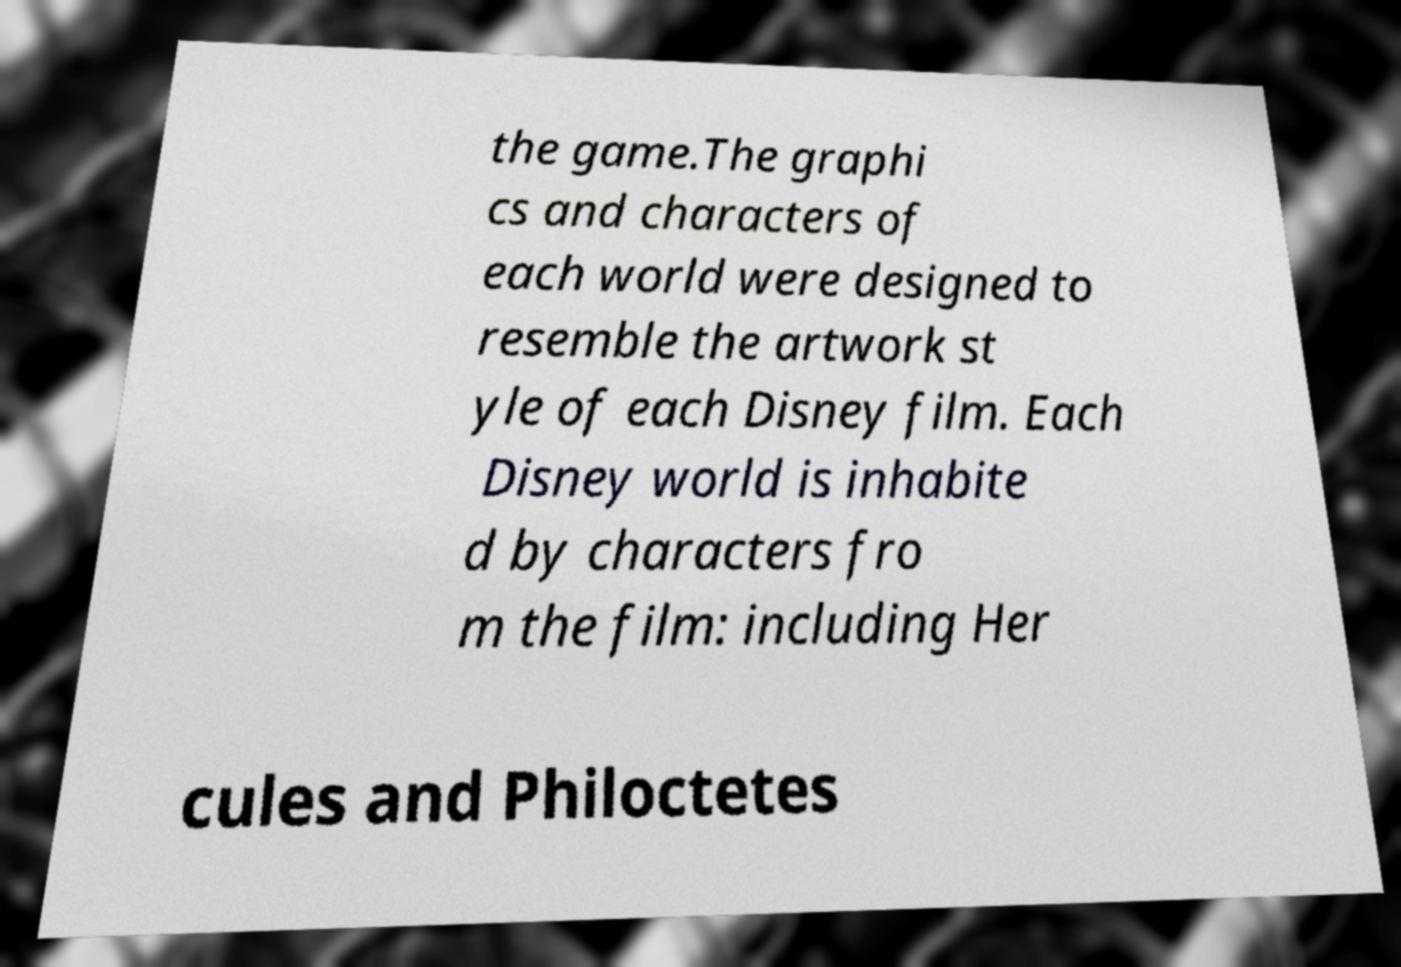What messages or text are displayed in this image? I need them in a readable, typed format. the game.The graphi cs and characters of each world were designed to resemble the artwork st yle of each Disney film. Each Disney world is inhabite d by characters fro m the film: including Her cules and Philoctetes 